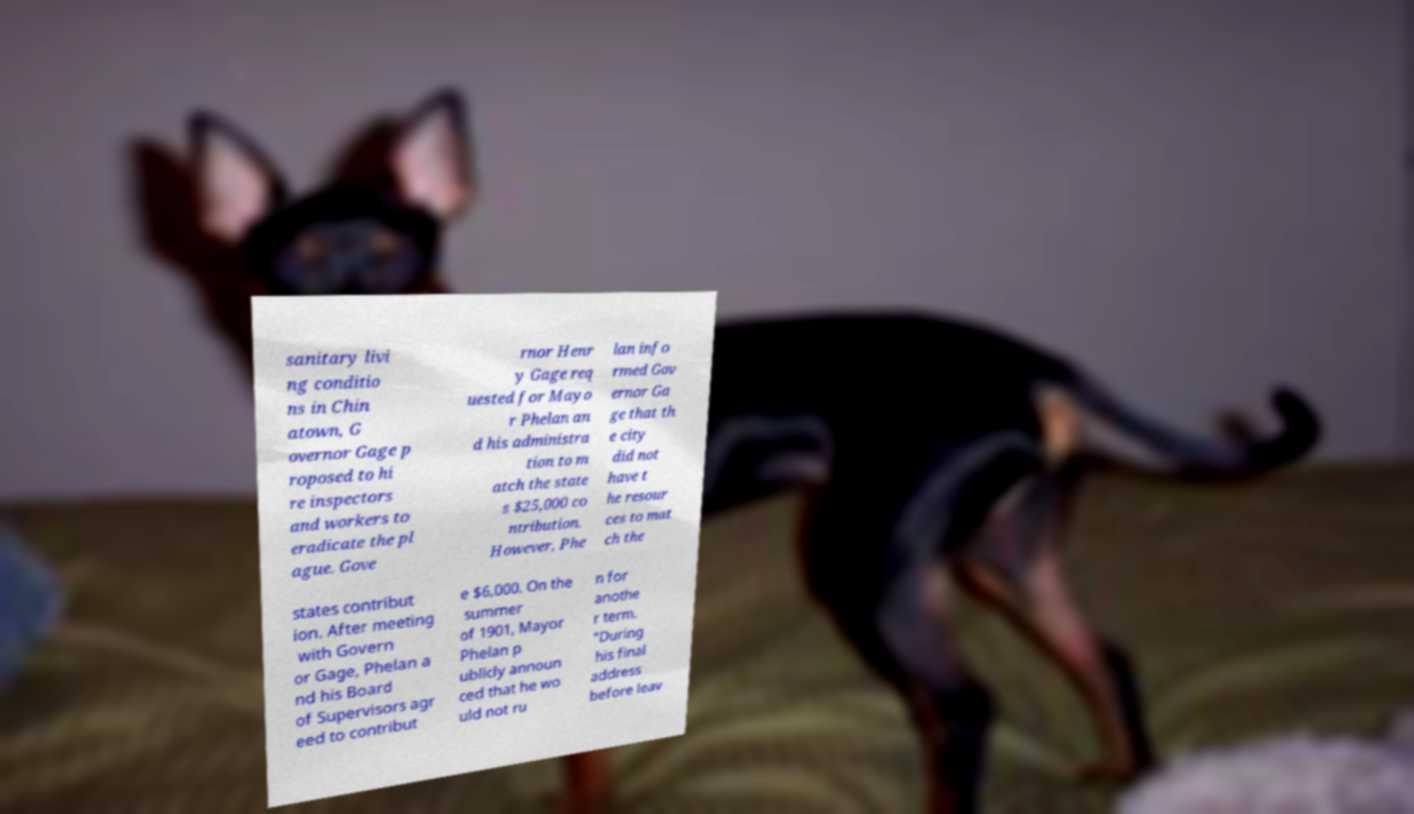Can you read and provide the text displayed in the image?This photo seems to have some interesting text. Can you extract and type it out for me? sanitary livi ng conditio ns in Chin atown, G overnor Gage p roposed to hi re inspectors and workers to eradicate the pl ague. Gove rnor Henr y Gage req uested for Mayo r Phelan an d his administra tion to m atch the state s $25,000 co ntribution. However, Phe lan info rmed Gov ernor Ga ge that th e city did not have t he resour ces to mat ch the states contribut ion. After meeting with Govern or Gage, Phelan a nd his Board of Supervisors agr eed to contribut e $6,000. On the summer of 1901, Mayor Phelan p ublicly announ ced that he wo uld not ru n for anothe r term. "During his final address before leav 